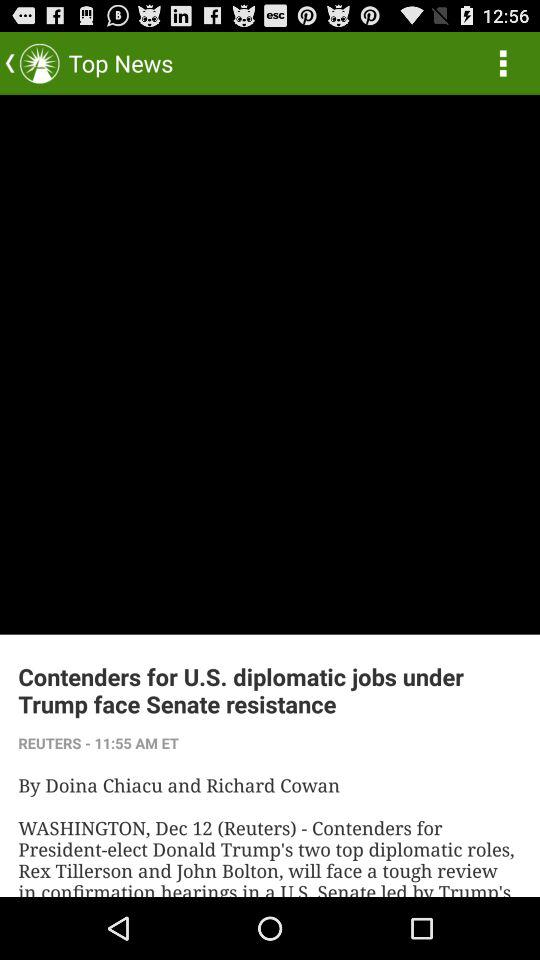What is the headline? The headline is "Contenders for U.S. diplomatic jobs under Trump face Senate resistance". 